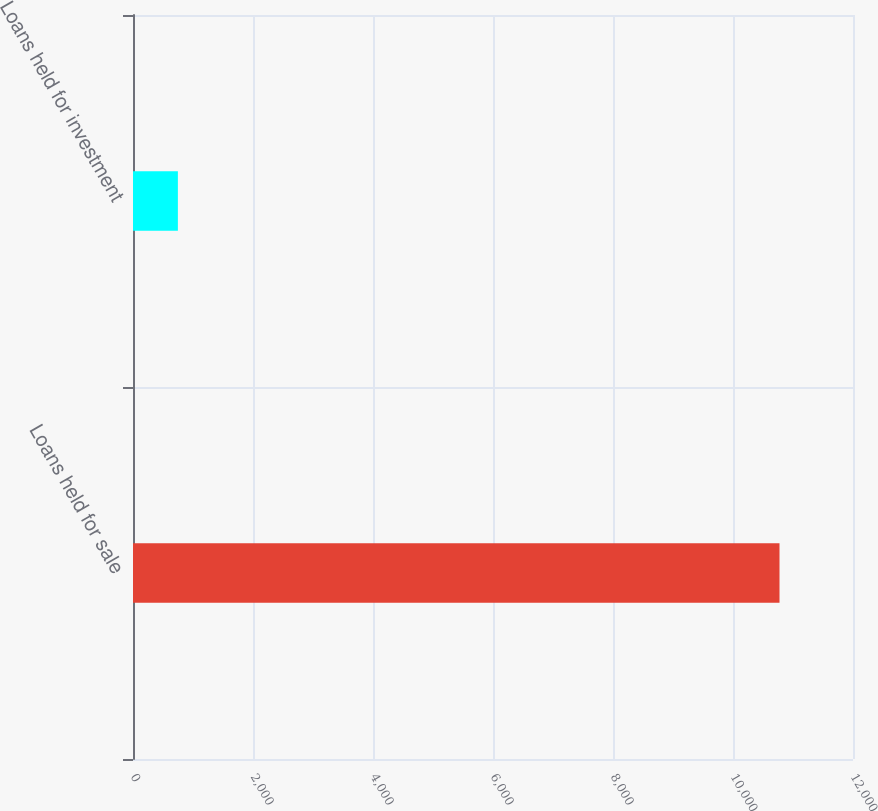<chart> <loc_0><loc_0><loc_500><loc_500><bar_chart><fcel>Loans held for sale<fcel>Loans held for investment<nl><fcel>10775<fcel>748<nl></chart> 